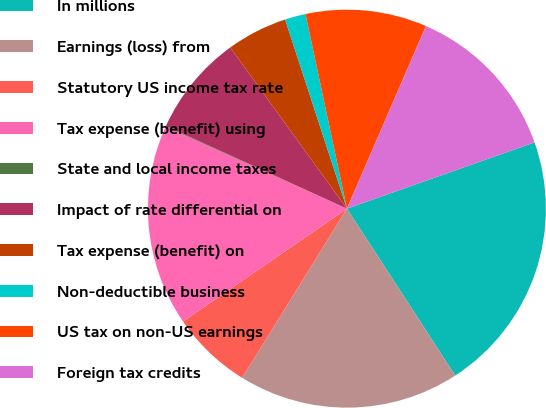Convert chart. <chart><loc_0><loc_0><loc_500><loc_500><pie_chart><fcel>In millions<fcel>Earnings (loss) from<fcel>Statutory US income tax rate<fcel>Tax expense (benefit) using<fcel>State and local income taxes<fcel>Impact of rate differential on<fcel>Tax expense (benefit) on<fcel>Non-deductible business<fcel>US tax on non-US earnings<fcel>Foreign tax credits<nl><fcel>21.25%<fcel>17.99%<fcel>6.58%<fcel>16.36%<fcel>0.06%<fcel>8.21%<fcel>4.95%<fcel>1.69%<fcel>9.84%<fcel>13.1%<nl></chart> 